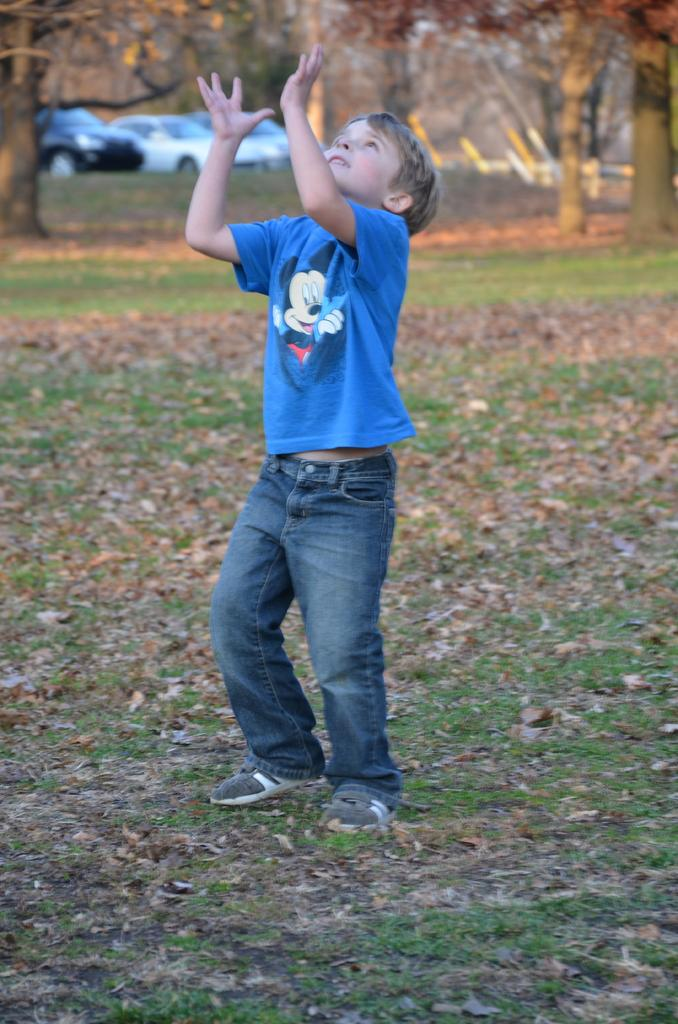What is the main subject of the image? There is a kid standing in the image. What type of surface is visible at the bottom of the image? There is grass and leaves at the bottom of the image. What can be seen in the background of the image? There are trees and cars in the background of the image. What type of way is the woman using to communicate with her partner in the image? There is no woman or partner present in the image, so this question cannot be answered. 